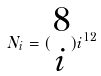<formula> <loc_0><loc_0><loc_500><loc_500>N _ { i } = ( \begin{matrix} 8 \\ i \end{matrix} ) i ^ { 1 2 }</formula> 